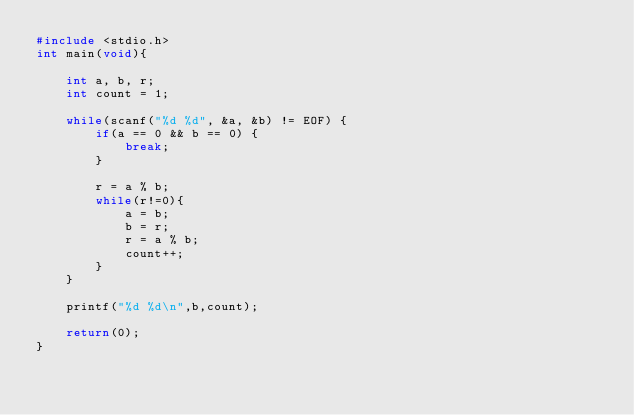<code> <loc_0><loc_0><loc_500><loc_500><_C_>#include <stdio.h>
int main(void){
    
    int a, b, r;
    int count = 1;
    
    while(scanf("%d %d", &a, &b) != EOF) {
        if(a == 0 && b == 0) {
            break;
        }
        
        r = a % b;
        while(r!=0){
            a = b;
            b = r;
            r = a % b;
            count++;
        }
    }
    
    printf("%d %d\n",b,count);
    
    return(0);
}
   
</code> 